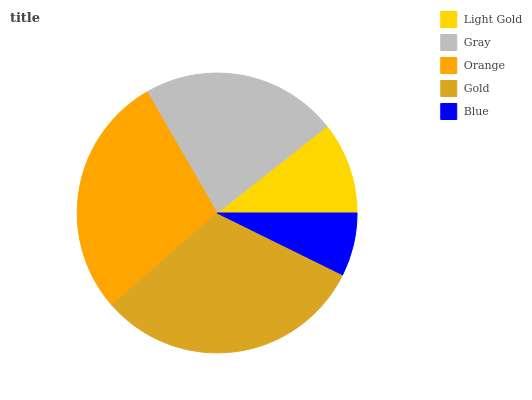Is Blue the minimum?
Answer yes or no. Yes. Is Gold the maximum?
Answer yes or no. Yes. Is Gray the minimum?
Answer yes or no. No. Is Gray the maximum?
Answer yes or no. No. Is Gray greater than Light Gold?
Answer yes or no. Yes. Is Light Gold less than Gray?
Answer yes or no. Yes. Is Light Gold greater than Gray?
Answer yes or no. No. Is Gray less than Light Gold?
Answer yes or no. No. Is Gray the high median?
Answer yes or no. Yes. Is Gray the low median?
Answer yes or no. Yes. Is Orange the high median?
Answer yes or no. No. Is Gold the low median?
Answer yes or no. No. 